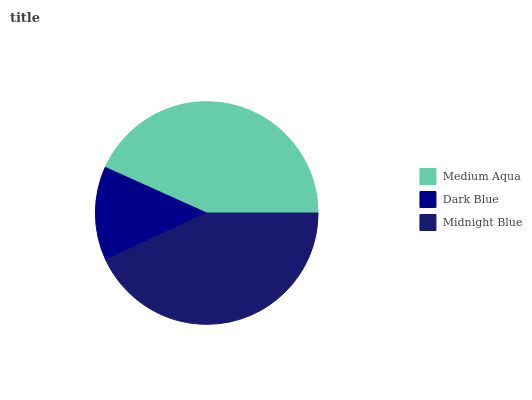Is Dark Blue the minimum?
Answer yes or no. Yes. Is Medium Aqua the maximum?
Answer yes or no. Yes. Is Midnight Blue the minimum?
Answer yes or no. No. Is Midnight Blue the maximum?
Answer yes or no. No. Is Midnight Blue greater than Dark Blue?
Answer yes or no. Yes. Is Dark Blue less than Midnight Blue?
Answer yes or no. Yes. Is Dark Blue greater than Midnight Blue?
Answer yes or no. No. Is Midnight Blue less than Dark Blue?
Answer yes or no. No. Is Midnight Blue the high median?
Answer yes or no. Yes. Is Midnight Blue the low median?
Answer yes or no. Yes. Is Dark Blue the high median?
Answer yes or no. No. Is Dark Blue the low median?
Answer yes or no. No. 